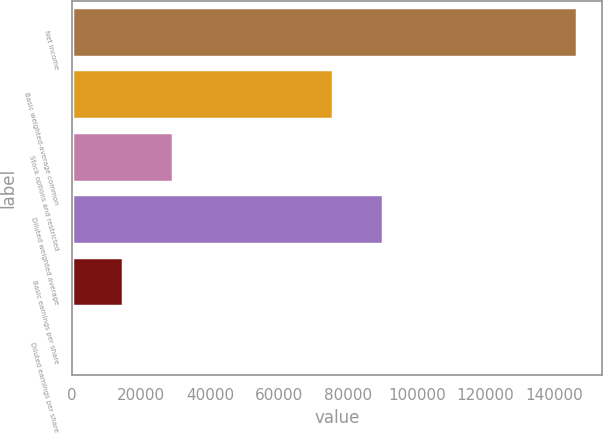Convert chart. <chart><loc_0><loc_0><loc_500><loc_500><bar_chart><fcel>Net income<fcel>Basic weighted-average common<fcel>Stock options and restricted<fcel>Diluted weighted average<fcel>Basic earnings per share<fcel>Diluted earnings per share<nl><fcel>146448<fcel>75629<fcel>29291.1<fcel>90273.6<fcel>14646.5<fcel>1.9<nl></chart> 